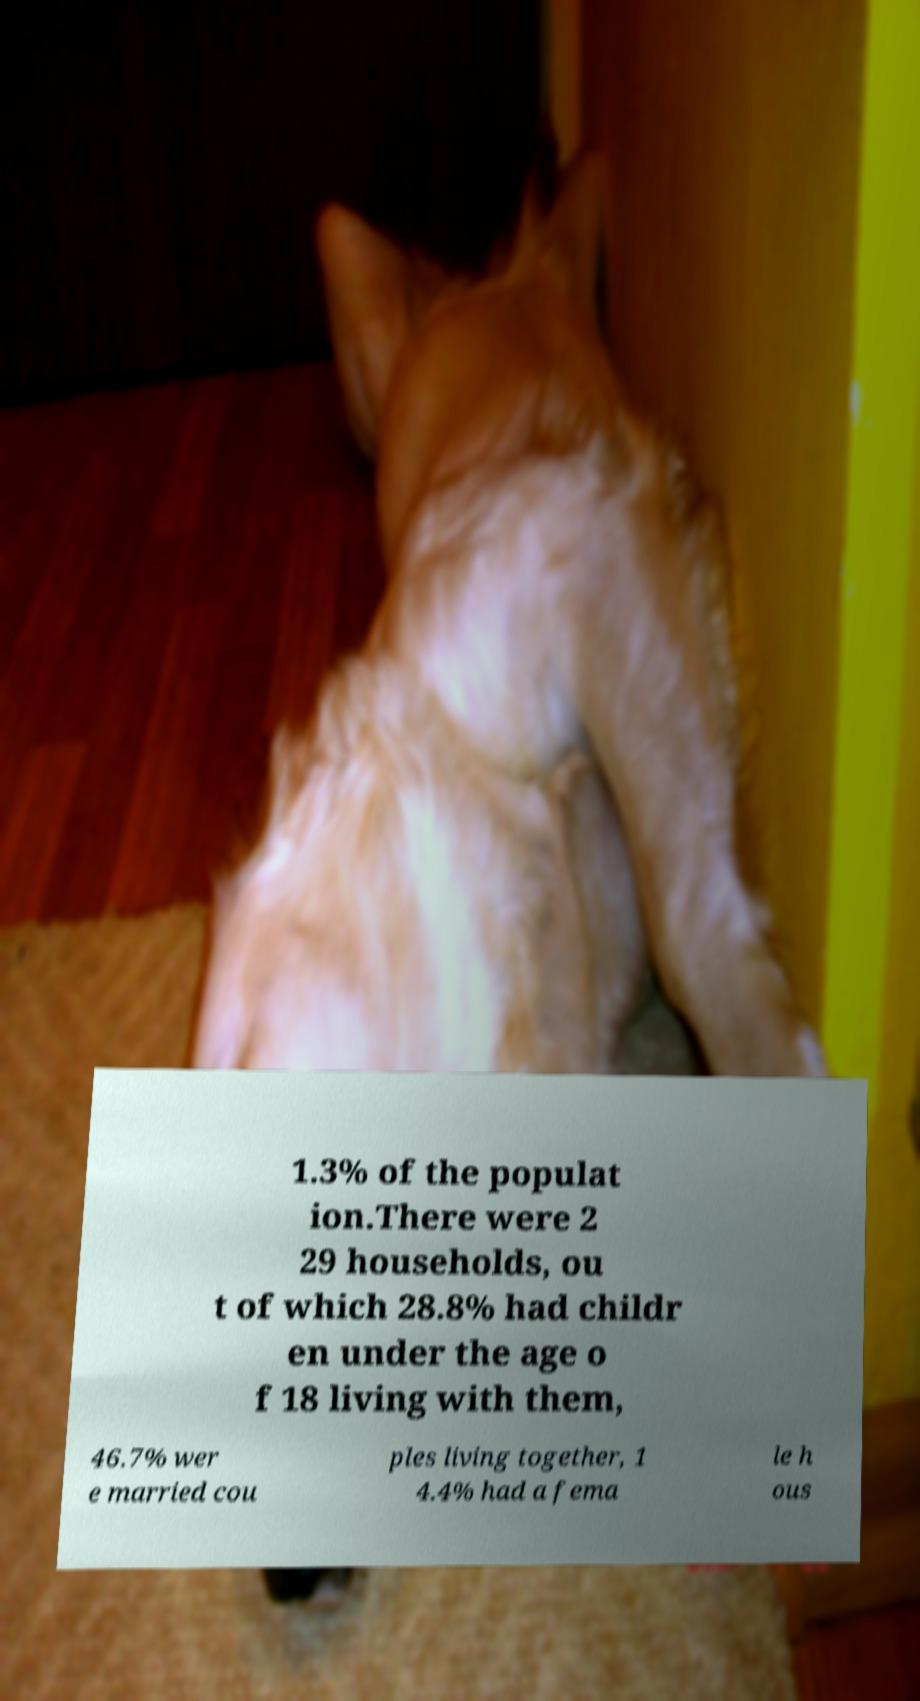Please read and relay the text visible in this image. What does it say? 1.3% of the populat ion.There were 2 29 households, ou t of which 28.8% had childr en under the age o f 18 living with them, 46.7% wer e married cou ples living together, 1 4.4% had a fema le h ous 